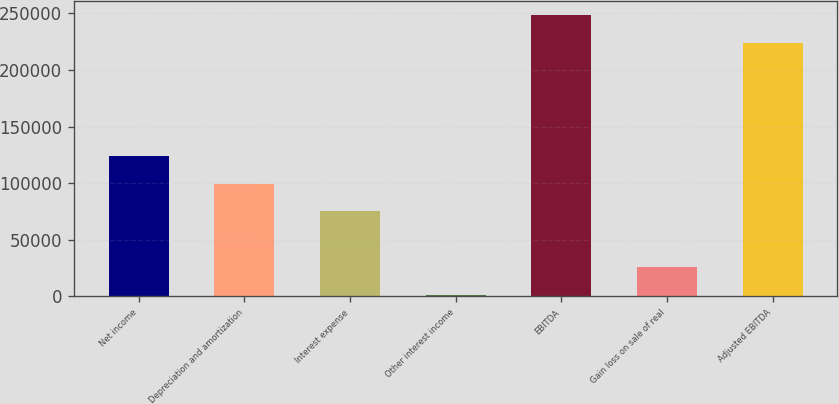Convert chart. <chart><loc_0><loc_0><loc_500><loc_500><bar_chart><fcel>Net income<fcel>Depreciation and amortization<fcel>Interest expense<fcel>Other interest income<fcel>EBITDA<fcel>Gain loss on sale of real<fcel>Adjusted EBITDA<nl><fcel>123768<fcel>99500<fcel>75232<fcel>1276<fcel>248171<fcel>25544<fcel>223903<nl></chart> 